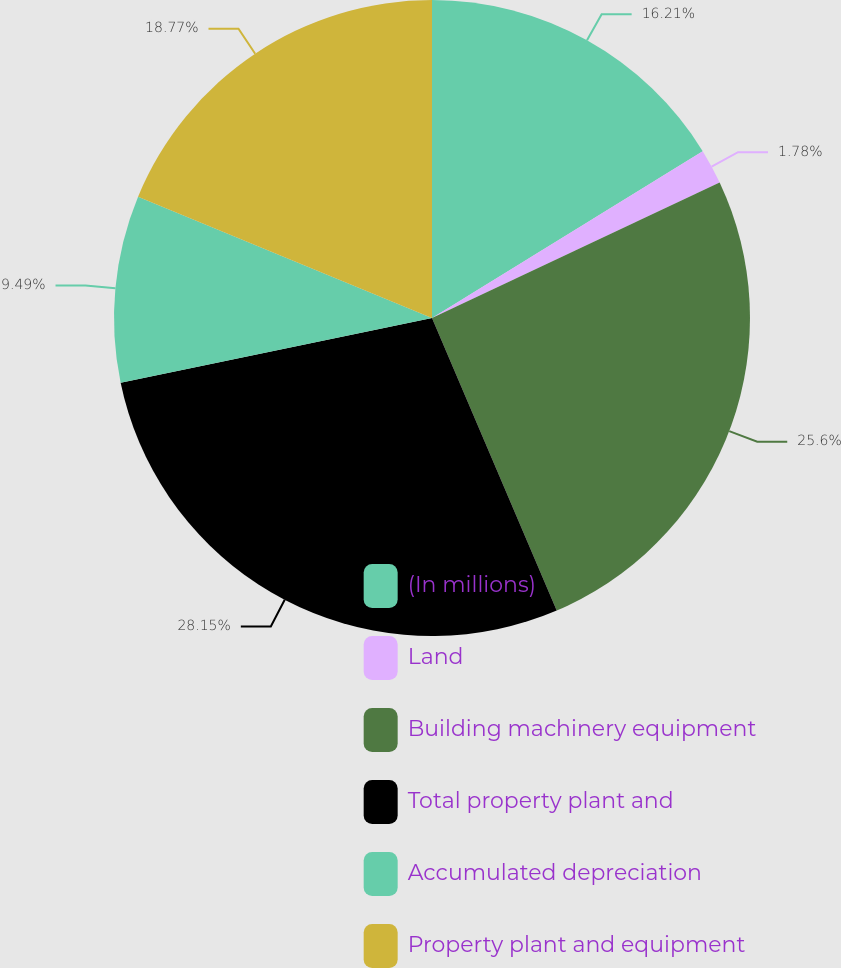Convert chart. <chart><loc_0><loc_0><loc_500><loc_500><pie_chart><fcel>(In millions)<fcel>Land<fcel>Building machinery equipment<fcel>Total property plant and<fcel>Accumulated depreciation<fcel>Property plant and equipment<nl><fcel>16.21%<fcel>1.78%<fcel>25.6%<fcel>28.16%<fcel>9.49%<fcel>18.77%<nl></chart> 